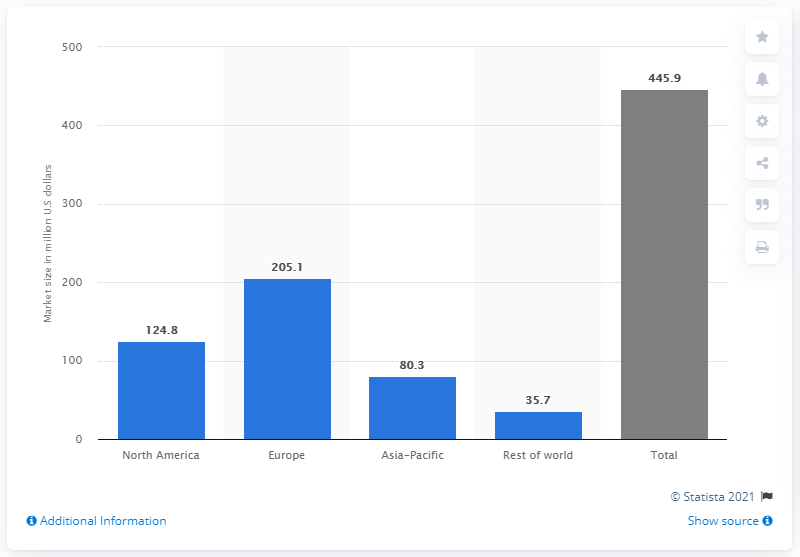Indicate a few pertinent items in this graphic. In 2017, the global human centric lighting market had a value of 445.9 million dollars. 